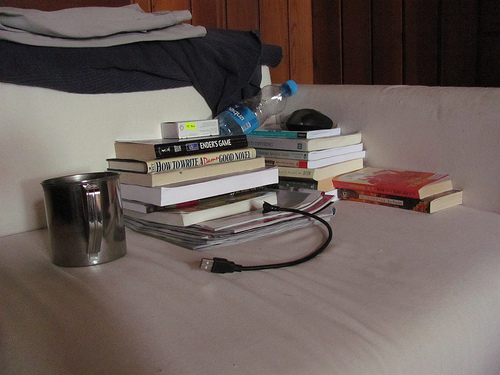<image>
Can you confirm if the book is under the cup? No. The book is not positioned under the cup. The vertical relationship between these objects is different. Is the mouse on the books? Yes. Looking at the image, I can see the mouse is positioned on top of the books, with the books providing support. Is the sofa on the mug? No. The sofa is not positioned on the mug. They may be near each other, but the sofa is not supported by or resting on top of the mug. Is there a cable to the right of the bottle? No. The cable is not to the right of the bottle. The horizontal positioning shows a different relationship. 